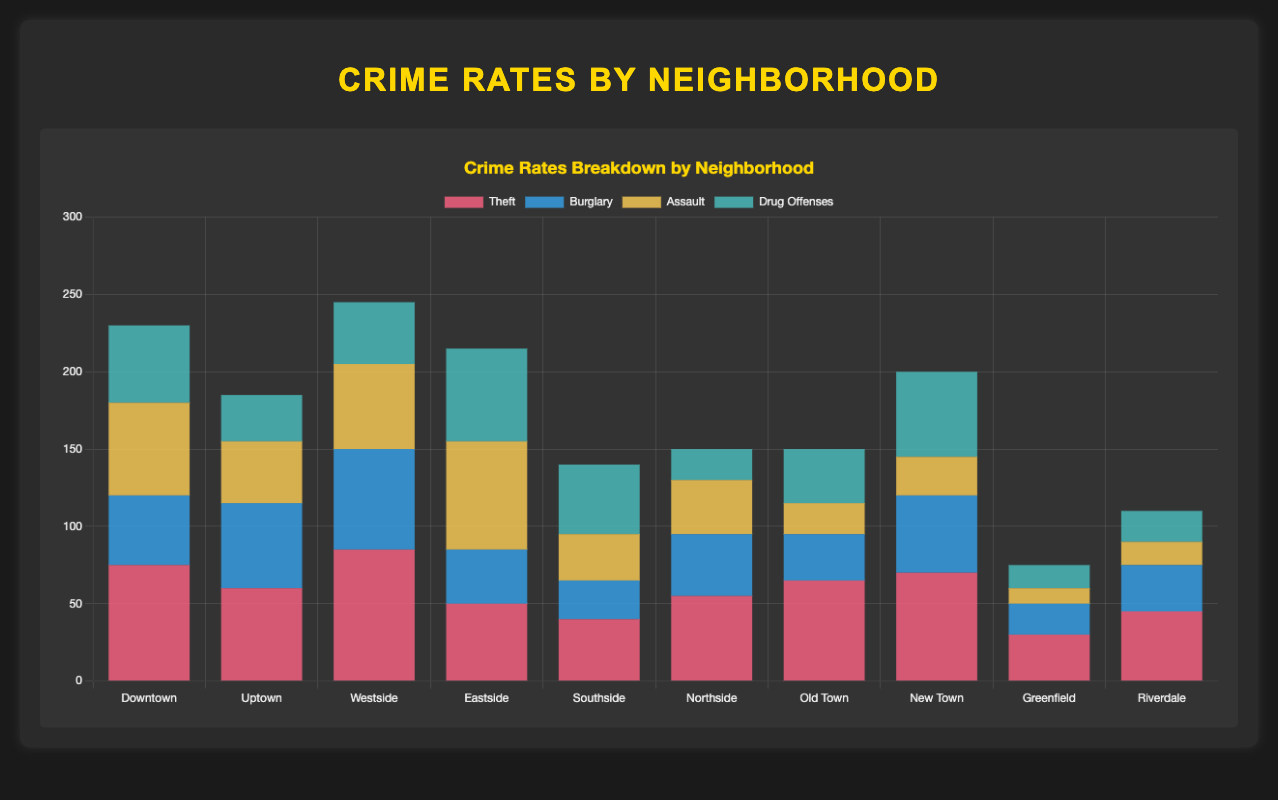What neighborhood has the highest total crime rate? To find the neighborhood with the highest total crime rate, sum the counts of all crime types in each neighborhood. Downtown: 75+45+60+50 = 230, Uptown: 60+55+40+30 = 185, Westside: 85+65+55+40 = 245, Eastside: 50+35+70+60 = 215, Southside: 40+25+30+45 = 140, Northside: 55+40+35+20 = 150, Old Town: 65+30+20+35 = 150, New Town: 70+50+25+55 = 200, Greenfield: 30+20+10+15 = 75, Riverdale: 45+30+15+20 = 110. The highest total is 245 in Westside.
Answer: Westside Which neighborhood has the fewest incidents of drug offenses, and how many are there? To determine this, compare the counts of drug offenses across all neighborhoods: Downtown: 50, Uptown: 30, Westside: 40, Eastside: 60, Southside: 45, Northside: 20, Old Town: 35, New Town: 55, Greenfield: 15, Riverdale: 20. The fewest is in Greenfield with 15 incidents.
Answer: Greenfield with 15 Compare the theft rates between Downtown and Westside. Which neighborhood has more theft incidents and by how much? Downtown has 75 incidents of theft, and Westside has 85. The difference is calculated as 85 - 75 = 10. Thus, Westside has 10 more theft incidents than Downtown.
Answer: Westside by 10 What is the combined total of burglary incidents in Northside and Southside? Northside has 40 burglary incidents, and Southside has 25. Adding them together: 40 + 25 = 65.
Answer: 65 Which type of crime is most frequent in Eastside, and what is the count? Assess the counts of each crime type in Eastside: theft: 50, burglary: 35, assault: 70, drug offenses: 60. The highest count is for assault with 70 incidents.
Answer: Assault with 70 What is the total number of assault incidents in all neighborhoods combined? Sum the assault counts from all neighborhoods: 60 (Downtown) + 40 (Uptown) + 55 (Westside) + 70 (Eastside) + 30 (Southside) + 35 (Northside) + 20 (Old Town) + 25 (New Town) + 10 (Greenfield) + 15 (Riverdale) = 360.
Answer: 360 Which neighborhood has the smallest total crime rate and what is that rate? Calculate the total crime rate for each neighborhood and find the smallest: Downtown: 230, Uptown: 185, Westside: 245, Eastside: 215, Southside: 140, Northside: 150, Old Town: 150, New Town: 200, Greenfield: 75, Riverdale: 110. The smallest total is in Greenfield with 75.
Answer: Greenfield with 75 What is the average number of theft incidents across all neighborhoods? To find the average, sum the theft incidents across all neighborhoods and divide by the number of neighborhoods. Total thefts = 75+60+85+50+40+55+65+70+30+45 = 575. There are 10 neighborhoods, so the average is 575 / 10 = 57.5.
Answer: 57.5 How does the number of burglary incidents in New Town compare to Uptown? New Town has 50 burglary incidents, and Uptown has 55. Comparing these, New Town has 5 fewer burglary incidents than Uptown.
Answer: New Town has 5 fewer 